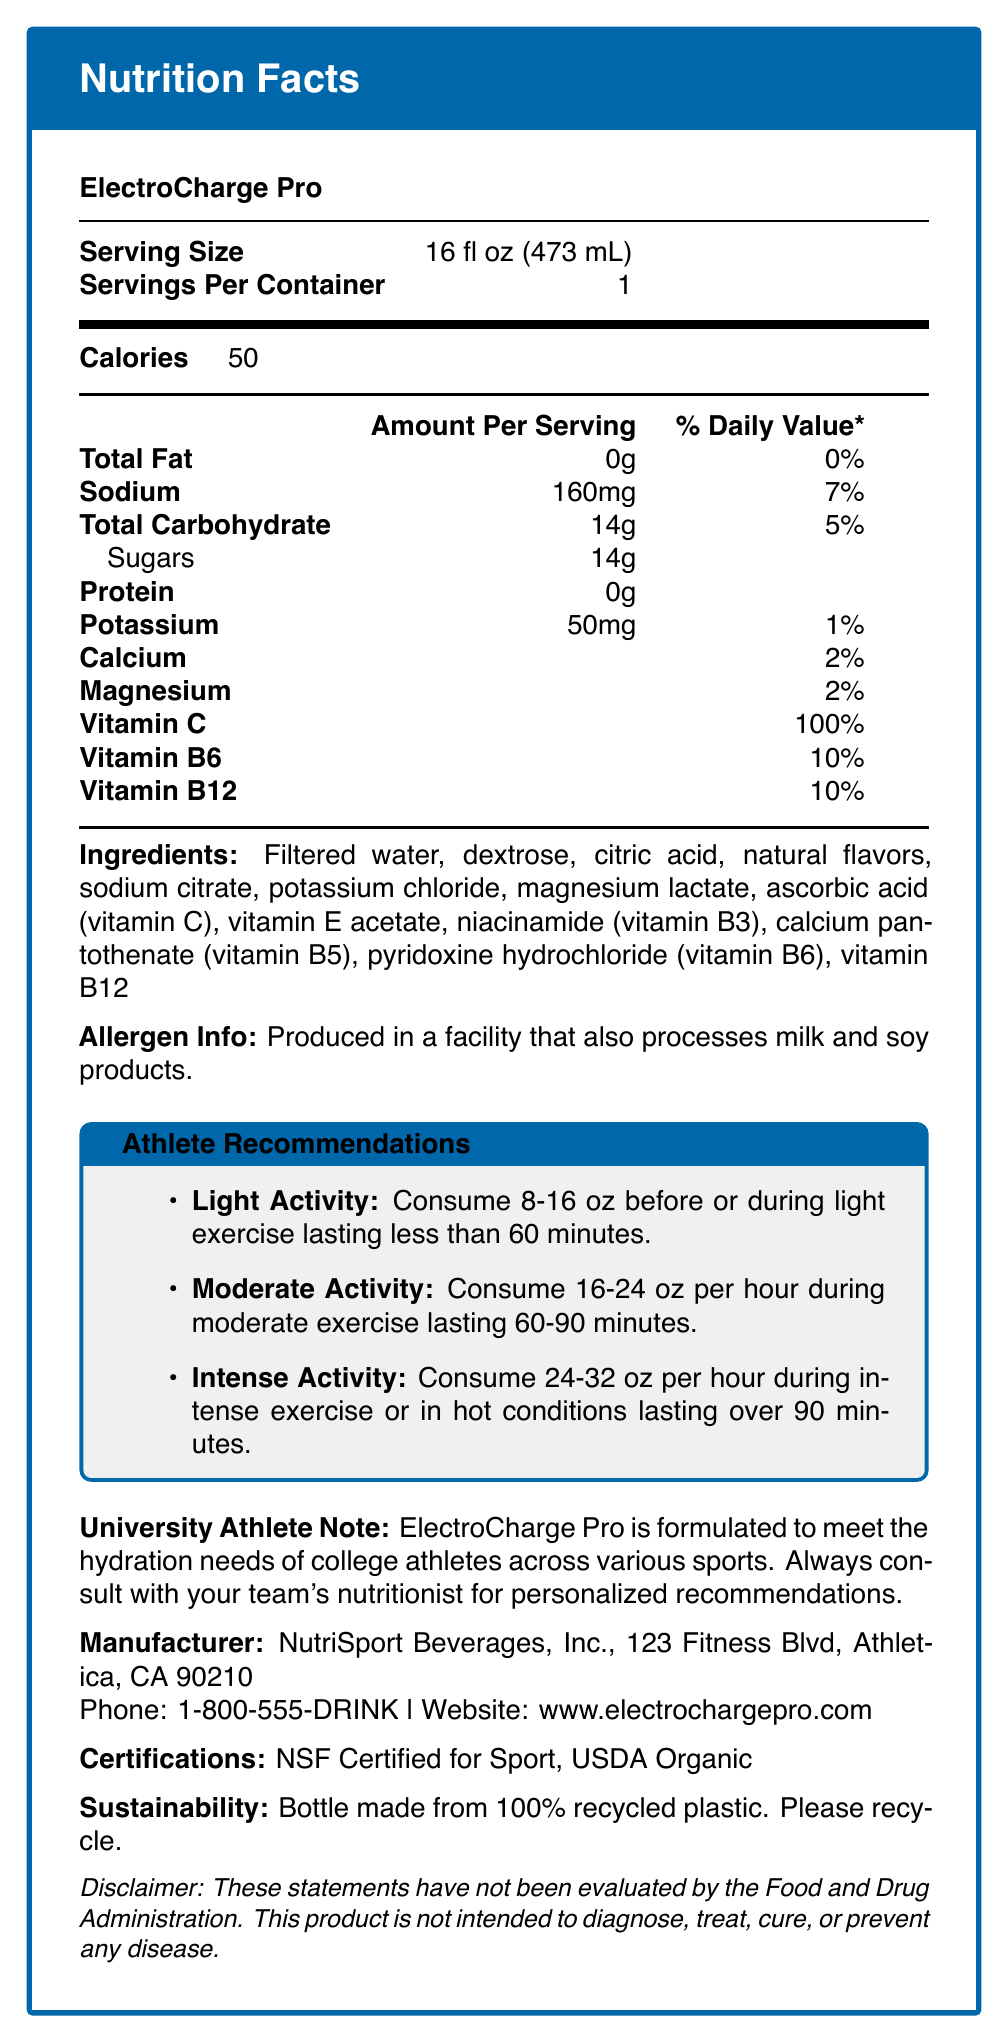What is the serving size of ElectroCharge Pro? The serving size is explicitly listed as "16 fl oz (473 mL)" in the Nutrition Facts section.
Answer: 16 fl oz (473 mL) How many calories are in one serving of ElectroCharge Pro? The document lists the calories per serving as 50.
Answer: 50 What is the amount of sodium in one serving? The amount of sodium per serving is shown as "160mg" in the Nutrition Facts.
Answer: 160mg List the vitamins and their respective daily values in ElectroCharge Pro. The Nutrition Facts list Vitamin C at 100% DV, Vitamin B6 at 10% DV, and Vitamin B12 at 10% DV.
Answer: Vitamin C: 100%, Vitamin B6: 10%, Vitamin B12: 10% What is the suggested intake for moderate activity? According to the Athlete Recommendations section, for moderate activity, one should consume 16-24 oz per hour during exercise lasting 60-90 minutes.
Answer: Consume 16-24 oz per hour during moderate exercise lasting 60-90 minutes. Which of the following ingredients is NOT listed in ElectroCharge Pro? 
A. Sodium citrate 
B. High fructose corn syrup 
C. Dextrose The ingredients list includes sodium citrate and dextrose, but not high fructose corn syrup.
Answer: B What is the percentage of daily value for Calcium in ElectroCharge Pro? 
A. 2% 
B. 5% 
C. 10% 
D. 15% The Nutrition Facts section lists Calcium at 2% DV.
Answer: A Is ElectroCharge Pro suitable for people with milk allergies? The allergen info specifies that it is produced in a facility that also processes milk products, posing a potential risk for individuals with milk allergies.
Answer: No Summarize the main idea of the ElectroCharge Pro Nutrition Facts document. The document details the nutritional content, serving recommendations, allergen information, manufacturer details, and certifications of ElectroCharge Pro.
Answer: ElectroCharge Pro is a sports drink designed to meet the hydration needs of athletes with a single serving size of 16 fl oz providing 50 calories and containing essential electrolytes, vitamins, and minerals. It offers recommendations for consumption based on exercise intensity and has certifications and sustainability efforts highlighted. What is the phone number for NutriSport Beverages, Inc.? The contact information for the manufacturer includes the phone number 1-800-555-DRINK, as specified in the Manufacturer section.
Answer: 1-800-555-DRINK Who should college athletes consult for personalized recommendations regarding ElectroCharge Pro? The University Athlete Note advises college athletes to consult with their team's nutritionist for personalized recommendations.
Answer: Their team's nutritionist What is the percent daily value of magnesium in ElectroCharge Pro? The Nutrition Facts lists the percent daily value of magnesium as 2%.
Answer: 2% How many grams of carbohydrates does ElectroCharge Pro contain? The total carbohydrates per serving is listed as 14g in the Nutrition Facts.
Answer: 14g Can ElectroCharge Pro diagnose, treat, cure, or prevent any disease? The disclaimer states that the product is not intended to diagnose, treat, cure, or prevent any disease.
Answer: No What is the recommended consumption for intense activity lasting over 90 minutes? The Athlete Recommendations section advises consuming 24-32 oz per hour for intense activities lasting over 90 minutes.
Answer: Consume 24-32 oz per hour during intense exercise or in hot conditions lasting over 90 minutes. How much protein does ElectroCharge Pro contain? The Nutrition Facts specify that the product contains 0g of protein.
Answer: 0g What is the main ingredient in ElectroCharge Pro? The first ingredient listed in the Ingredients section is filtered water.
Answer: Filtered water How should the bottle of ElectroCharge Pro be disposed of? The sustainability info indicates that the bottle is made from 100% recycled plastic and should be recycled.
Answer: Please recycle Do the statements in the document indicate that the product has been evaluated by the Food and Drug Administration? The disclaimer states that these statements have not been evaluated by the Food and Drug Administration.
Answer: No What does NSF Certified for Sport and USDA Organic refer to in the document? The document lists NSF Certified for Sport and USDA Organic under certifications, indicating that the product has these certifications.
Answer: Certifications that ElectroCharge Pro holds Who is the intended primary audience for ElectroCharge Pro based on the document content? The University Athlete Note and Athlete Recommendations focus on college athletes, indicating they are the primary audience.
Answer: College athletes What is the main flavoring ingredient in ElectroCharge Pro? The Ingredients section lists natural flavors as one of the components, indicating they are used for flavoring.
Answer: Natural flavors Is there any information about the cost of ElectroCharge Pro in the document? The document does not provide any information regarding the price or cost of ElectroCharge Pro.
Answer: Cannot be determined 